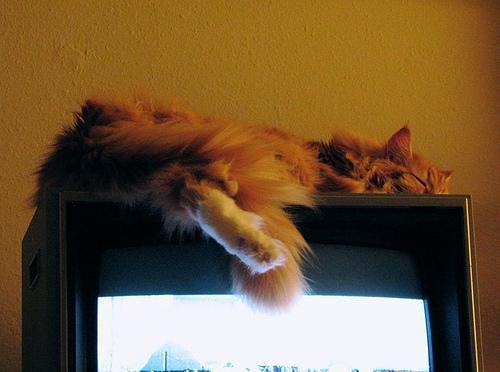How many people are cutting cake in the image?
Give a very brief answer. 0. 